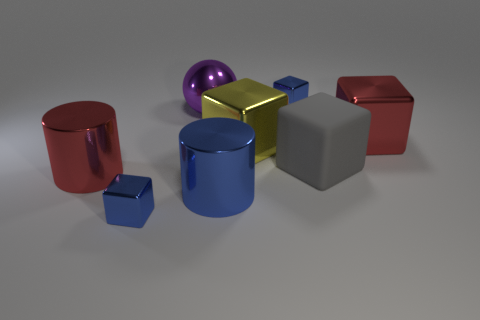Subtract all gray cubes. How many cubes are left? 4 Subtract all green blocks. Subtract all red cylinders. How many blocks are left? 5 Add 1 large yellow things. How many objects exist? 9 Subtract all cylinders. How many objects are left? 6 Add 8 large metal cylinders. How many large metal cylinders are left? 10 Add 6 small red metallic blocks. How many small red metallic blocks exist? 6 Subtract 0 gray spheres. How many objects are left? 8 Subtract all big yellow metal blocks. Subtract all purple metal things. How many objects are left? 6 